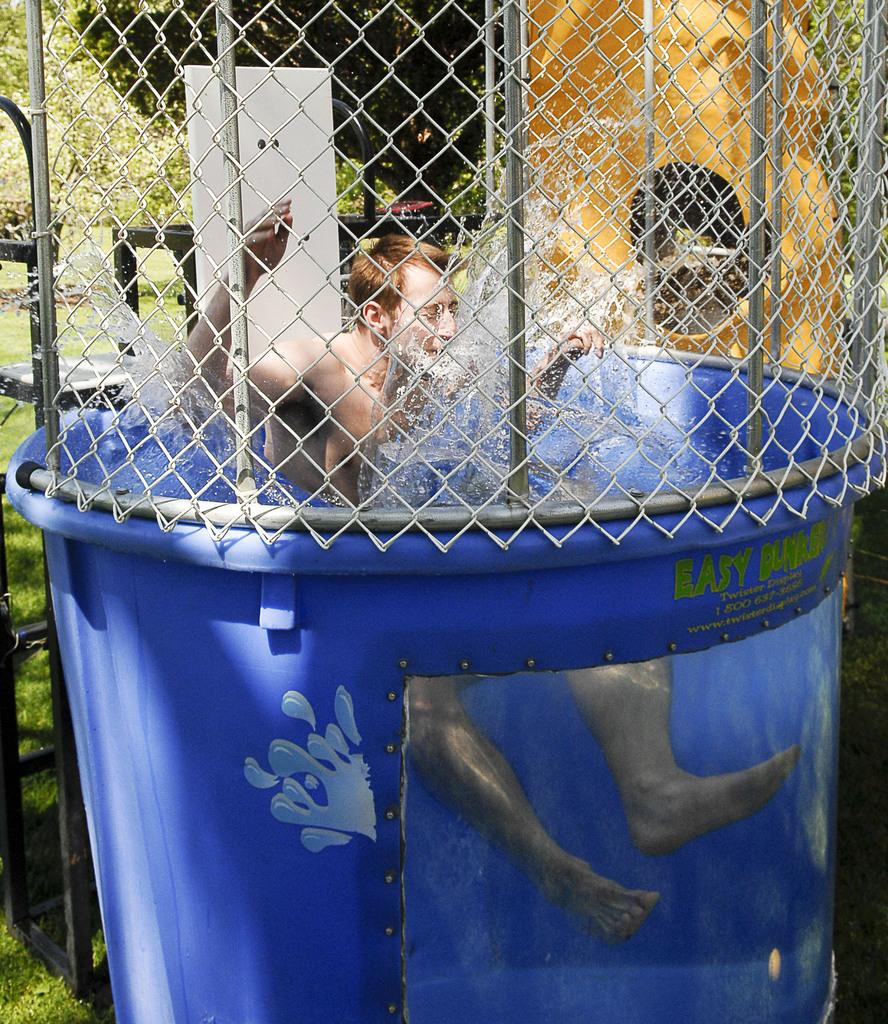What is the man in the image doing? The man is sitting in a tub in the image. What is the man's location in relation to the water? The man is in the water. What can be seen in the background of the image? There is a fence, trees, and grass visible in the image. Are there any other objects present in the image besides the man and the tub? Yes, there are other objects present in the image. What type of thought is the man having while sitting in the tub? There is no indication of the man's thoughts in the image, so it cannot be determined from the picture. 